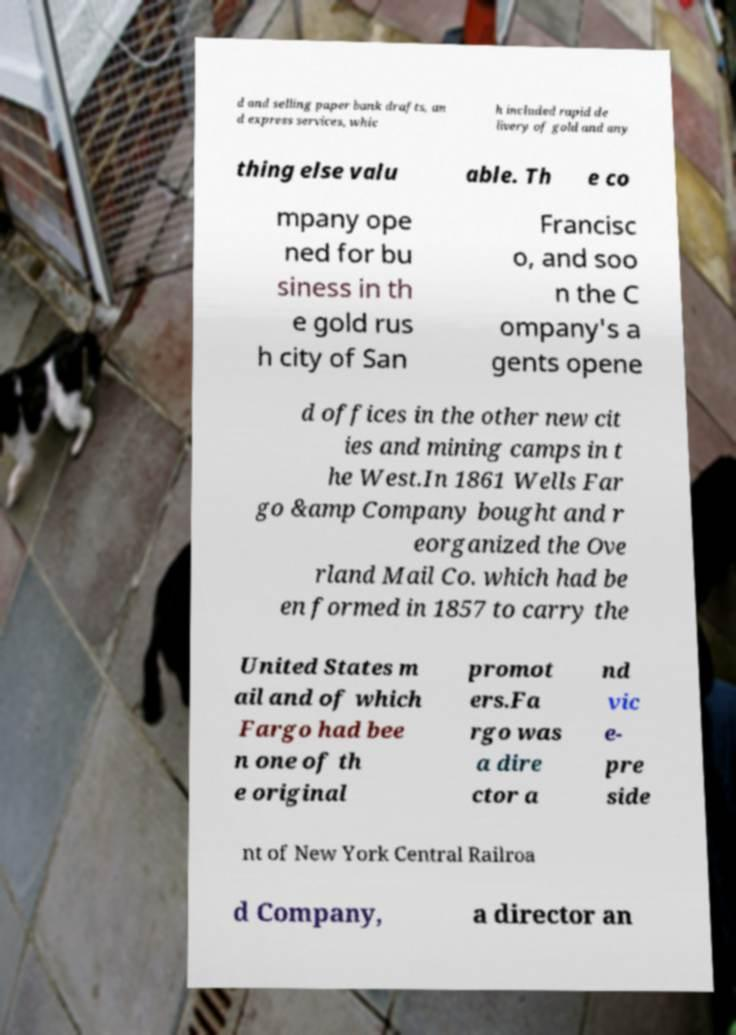Could you extract and type out the text from this image? d and selling paper bank drafts, an d express services, whic h included rapid de livery of gold and any thing else valu able. Th e co mpany ope ned for bu siness in th e gold rus h city of San Francisc o, and soo n the C ompany's a gents opene d offices in the other new cit ies and mining camps in t he West.In 1861 Wells Far go &amp Company bought and r eorganized the Ove rland Mail Co. which had be en formed in 1857 to carry the United States m ail and of which Fargo had bee n one of th e original promot ers.Fa rgo was a dire ctor a nd vic e- pre side nt of New York Central Railroa d Company, a director an 